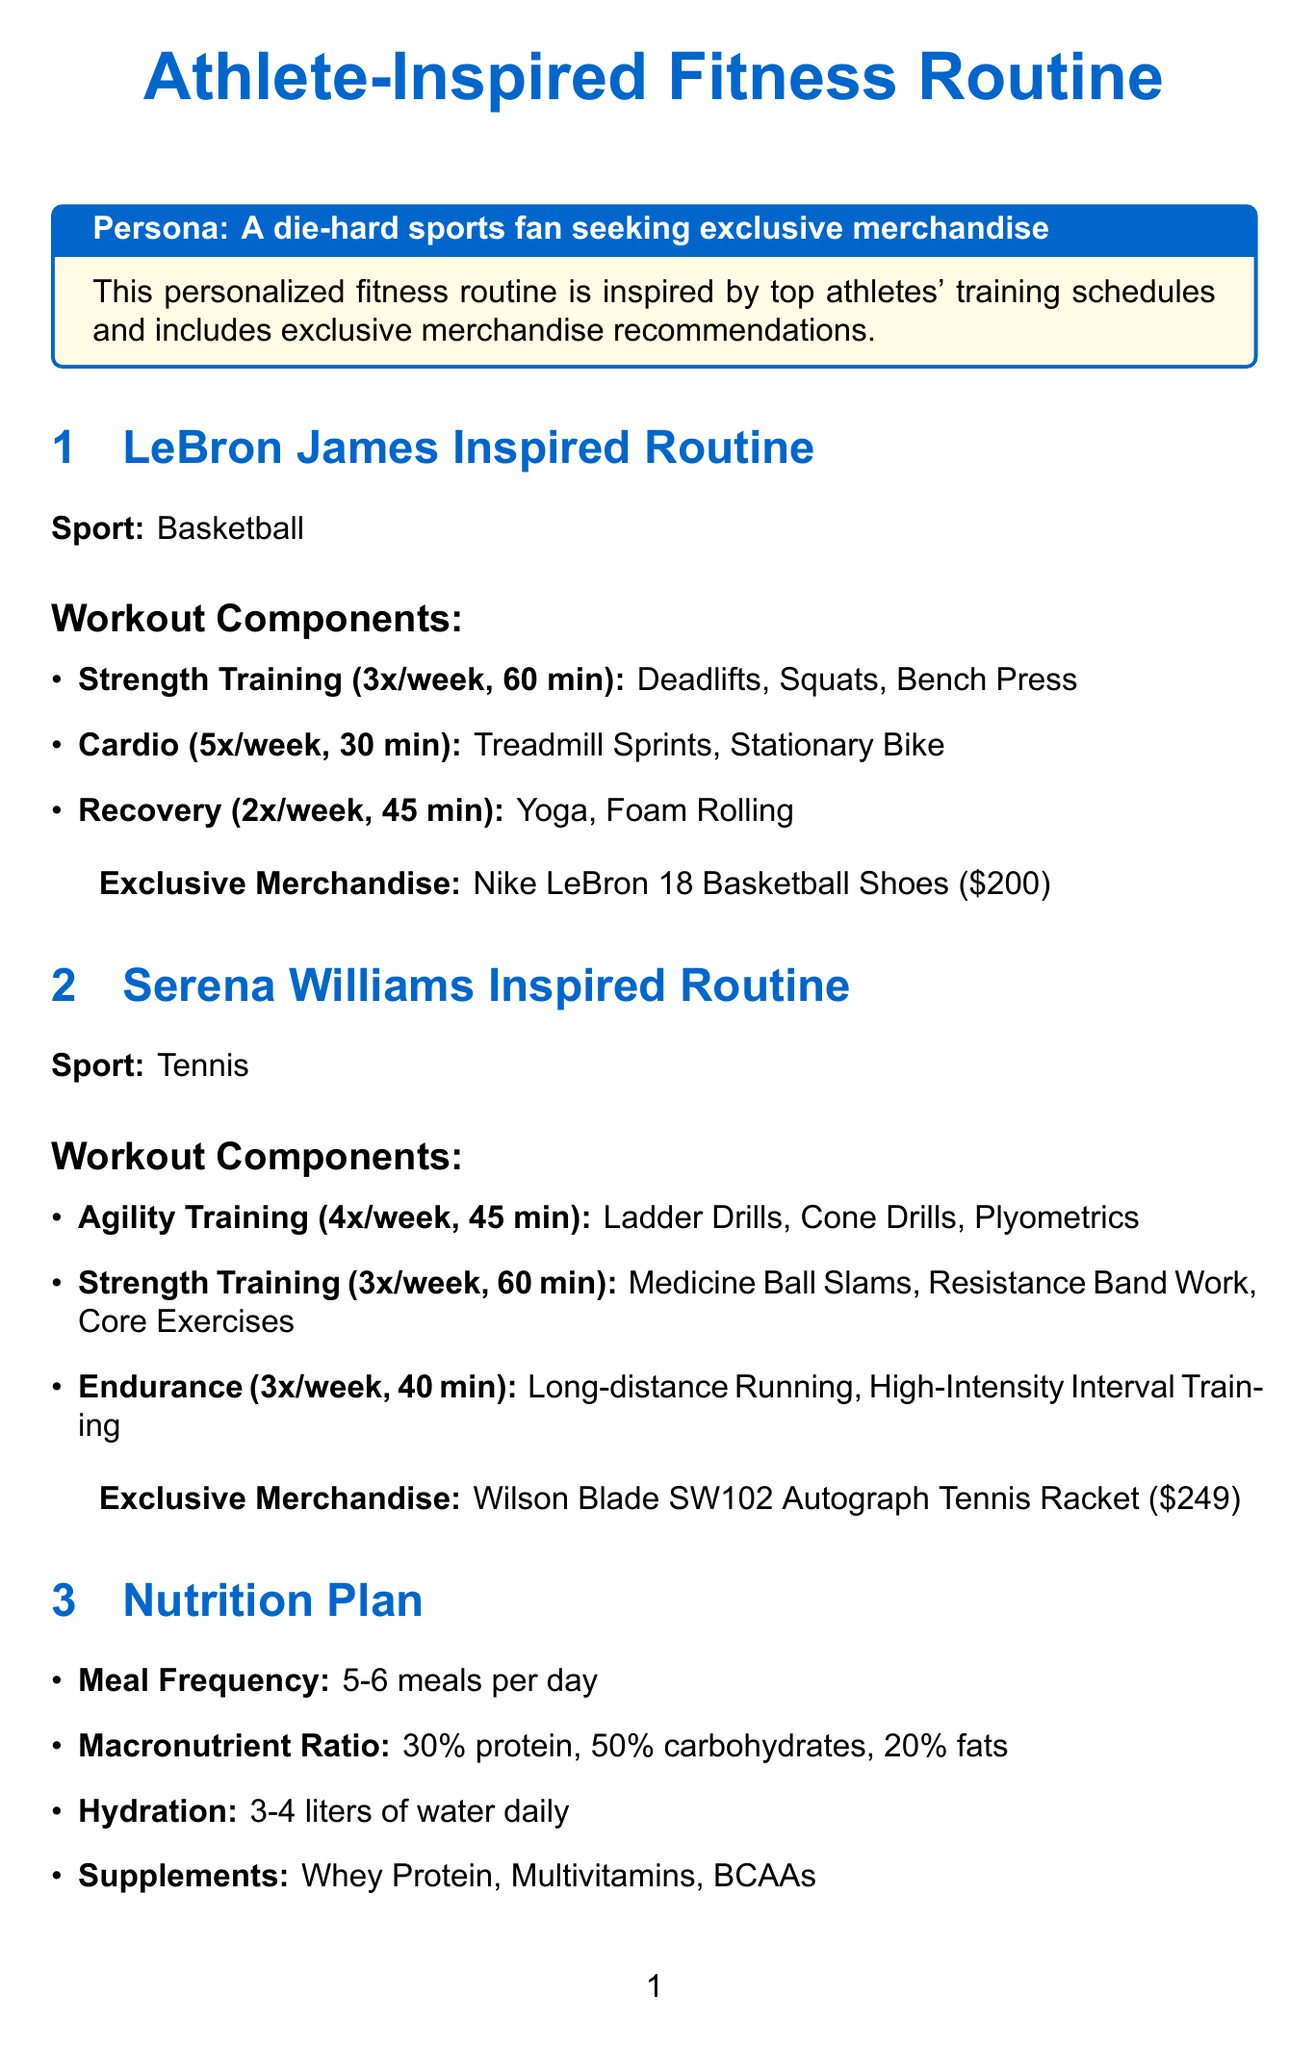What sport does LeBron James play? The document specifies that LeBron James plays basketball.
Answer: Basketball How many times a week does Serena Williams train for agility? The document states that Serena Williams performs agility training four times per week.
Answer: 4 times per week What is the duration of the strength training in LeBron's routine? The document mentions that each strength training session lasts 60 minutes.
Answer: 60 minutes What is the price of the Nike LeBron 18 Basketball Shoes? The document lists the price of the shoes as $200.
Answer: $200 How many meals are recommended in the nutrition plan? The document indicates that 5-6 meals are recommended per day.
Answer: 5-6 meals What is the frequency of massage therapy in the recovery techniques? The document states that massage therapy is recommended once per week.
Answer: Once per week What hydration amount is suggested in the nutrition plan? The document specifies a hydration recommendation of 3-4 liters of water daily.
Answer: 3-4 liters Which motivational quote is attributed to Michael Jordan? The document includes a quote from Michael Jordan about missing shots and failing.
Answer: "I've missed more than 9,000 shots..." What feature does the Fitbit Sense 2 Advanced Smartwatch include? The document lists the ECG app as one of the features of the smartwatch.
Answer: ECG app 